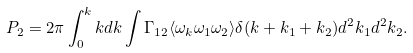<formula> <loc_0><loc_0><loc_500><loc_500>P _ { 2 } = 2 \pi \int _ { 0 } ^ { k } k d k \int \Gamma _ { 1 2 } \langle \omega _ { k } \omega _ { 1 } \omega _ { 2 } \rangle \delta ( k + k _ { 1 } + k _ { 2 } ) d ^ { 2 } k _ { 1 } d ^ { 2 } k _ { 2 } .</formula> 